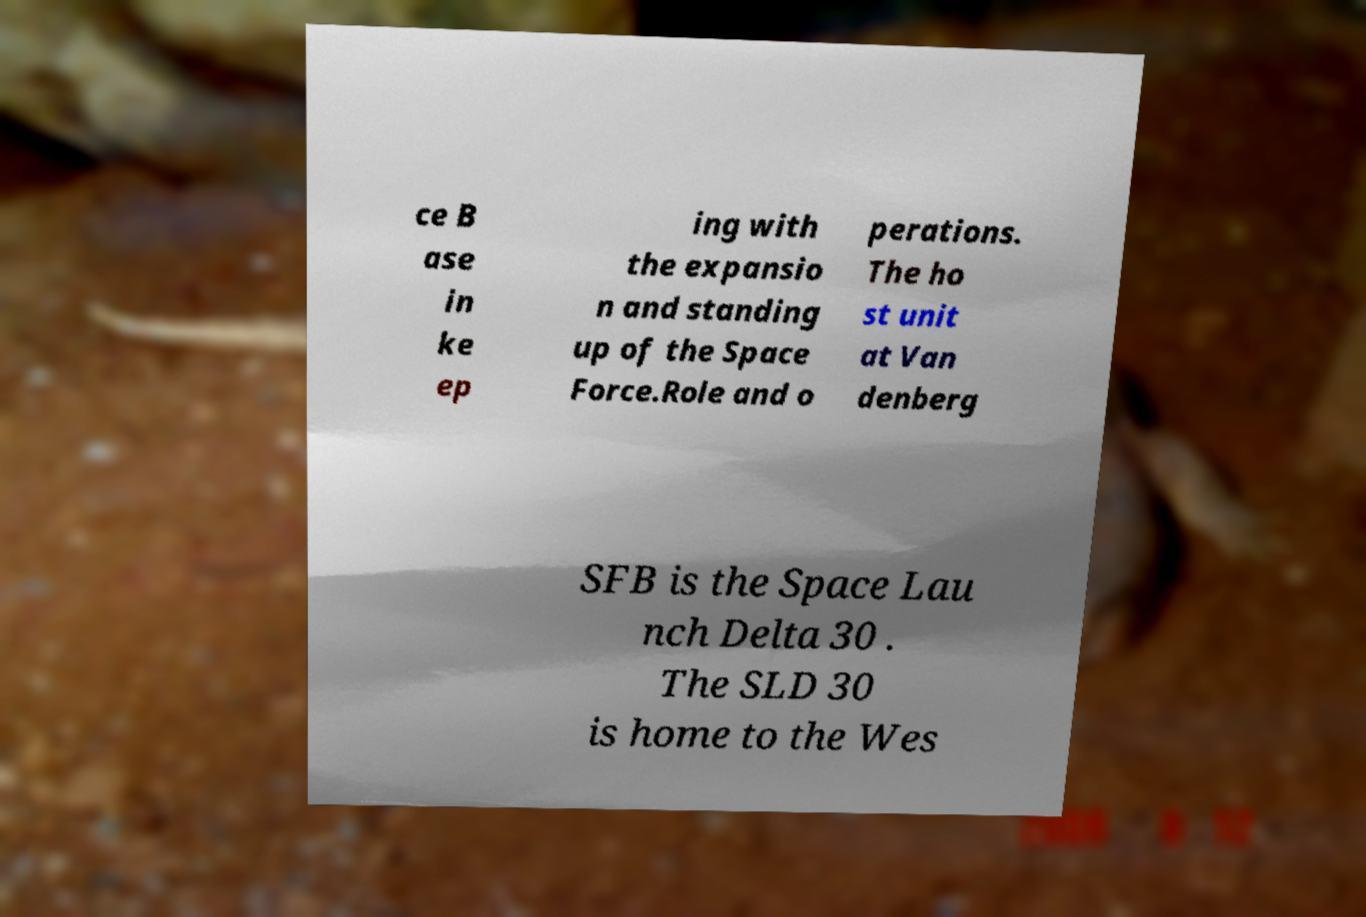Please identify and transcribe the text found in this image. ce B ase in ke ep ing with the expansio n and standing up of the Space Force.Role and o perations. The ho st unit at Van denberg SFB is the Space Lau nch Delta 30 . The SLD 30 is home to the Wes 